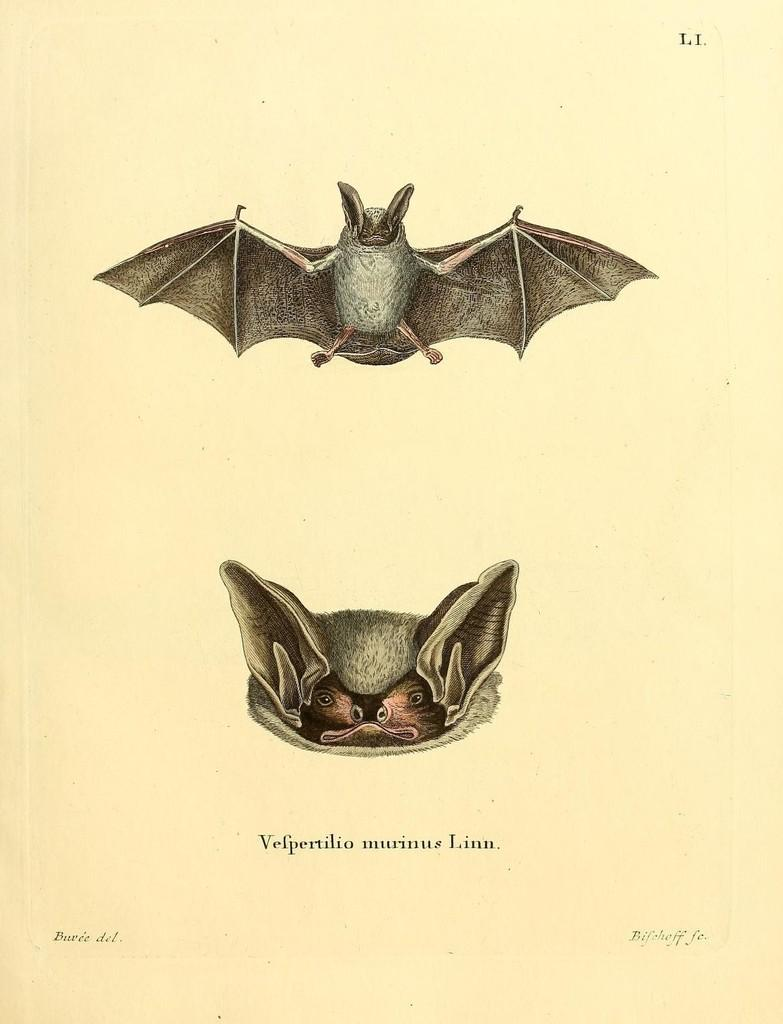What is depicted in the image? There is a picture of two bats in the image. What invention is being used by the bats in the image? There is no invention present in the image; it features a picture of two bats. What type of beast is shown interacting with the bats in the image? There is no other beast depicted in the image; only the two bats are present. 